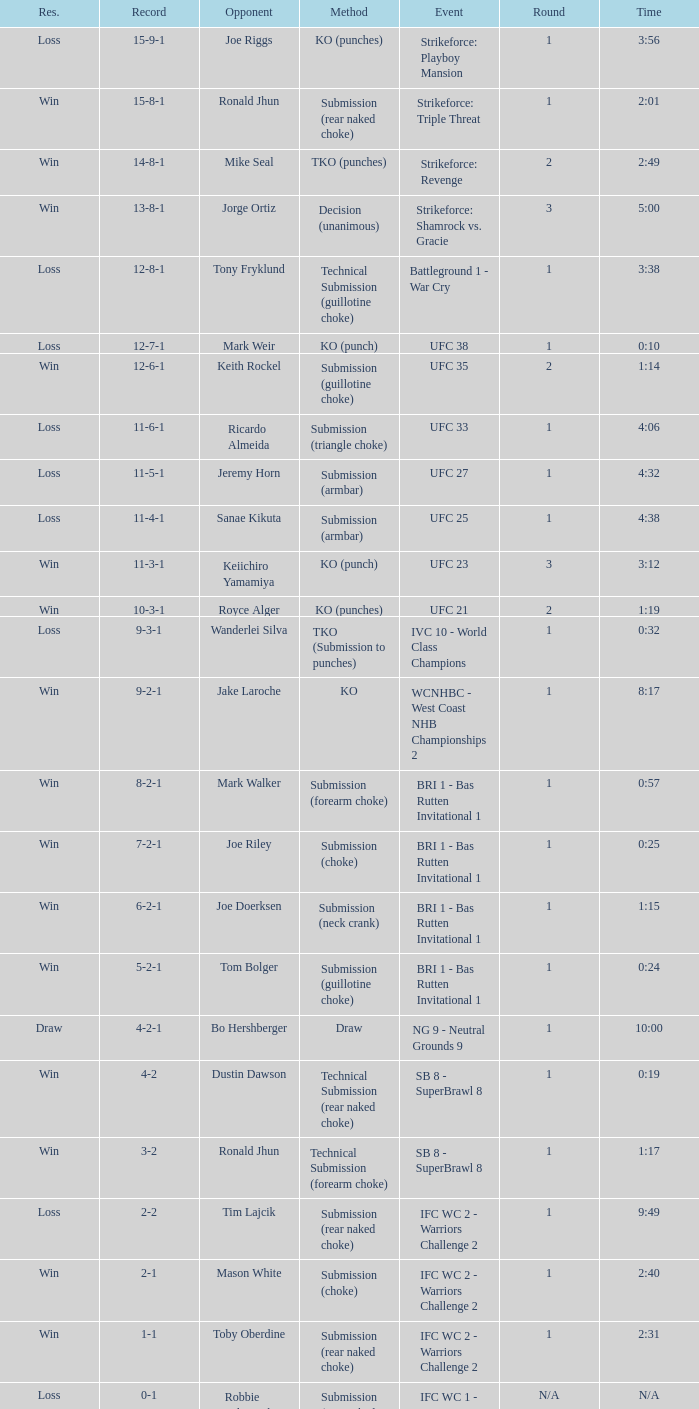What was the resolution for the fight against tom bolger by submission (guillotine choke)? Win. 